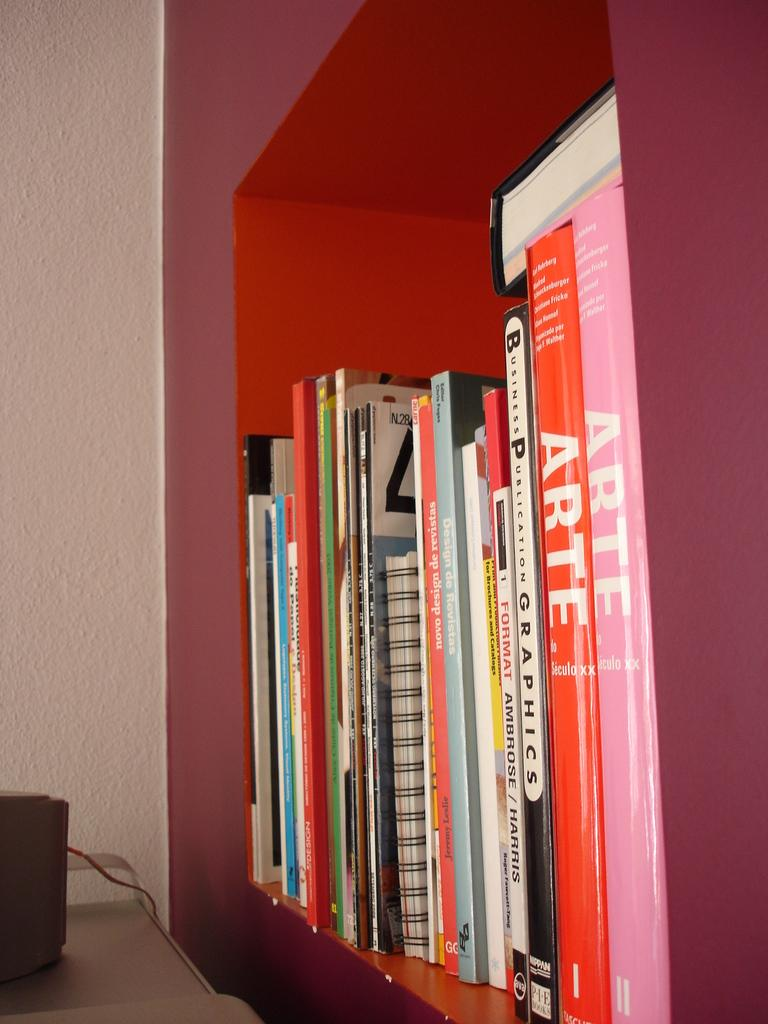<image>
Render a clear and concise summary of the photo. The black and white book on the shelf is about Business Publication Graphics. 